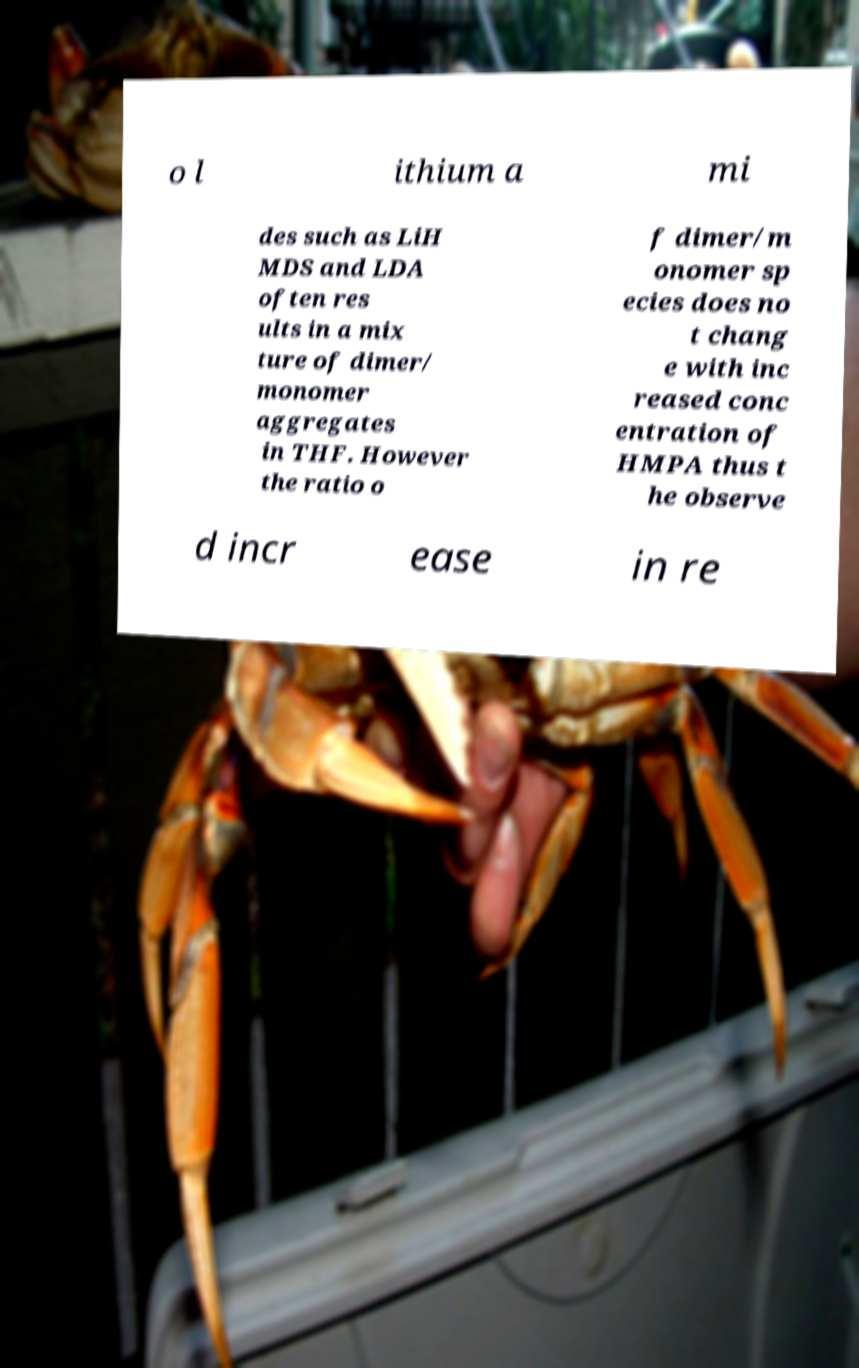What messages or text are displayed in this image? I need them in a readable, typed format. o l ithium a mi des such as LiH MDS and LDA often res ults in a mix ture of dimer/ monomer aggregates in THF. However the ratio o f dimer/m onomer sp ecies does no t chang e with inc reased conc entration of HMPA thus t he observe d incr ease in re 